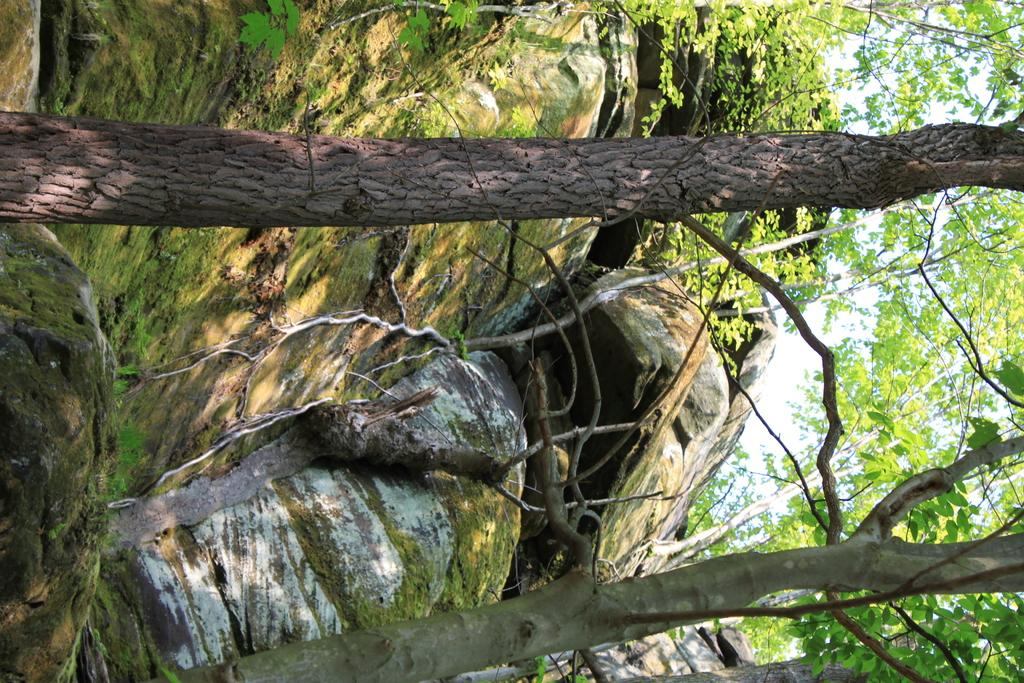What type of natural elements can be seen in the image? There are rocks and trees in the image. What part of the natural environment is visible in the image? The sky is visible in the image. How many friends are sitting on the cloth in the image? There is no cloth or friends present in the image. 